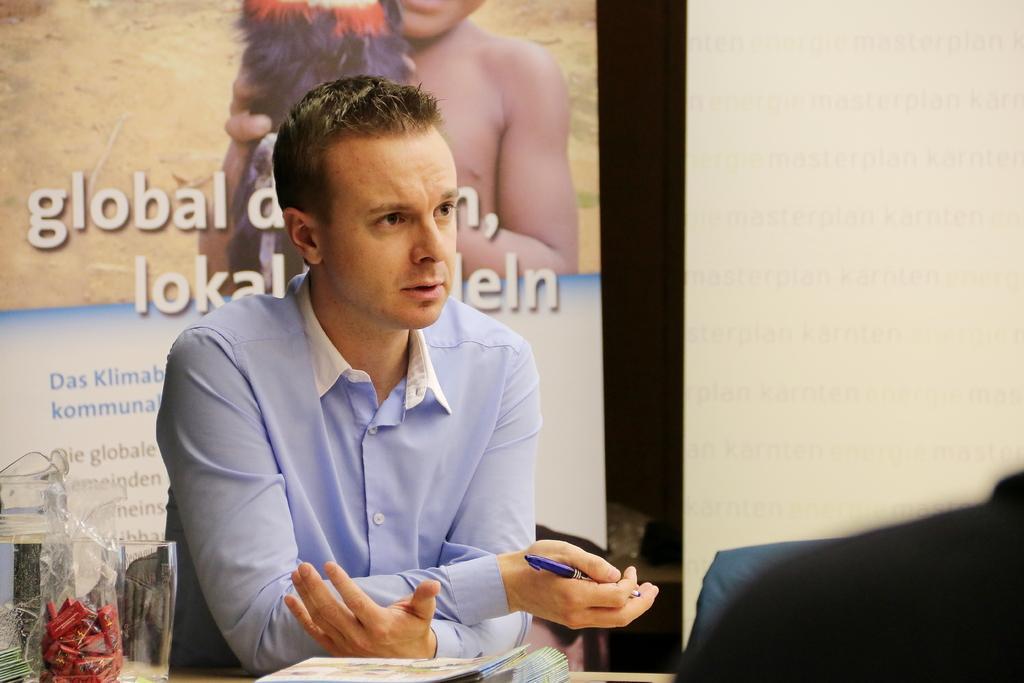Please provide a concise description of this image. In this image in front there is a person sitting on the chair. In front of him there is a table. On top of the table there are books, glass and a few other objects. Behind the person there is a board. On the backside there is a wall. 